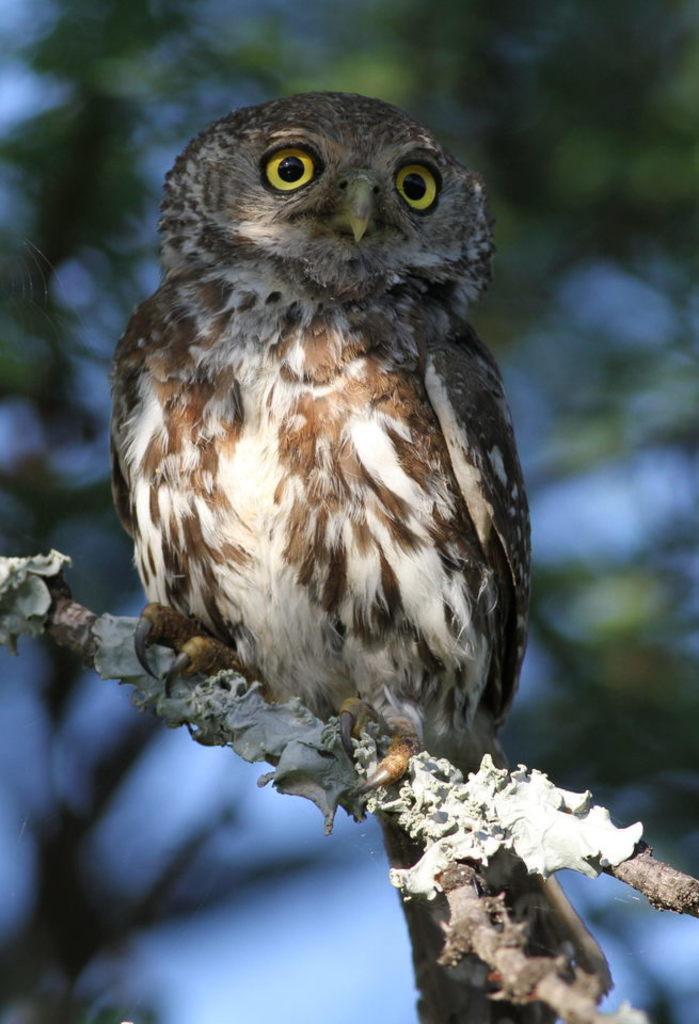In one or two sentences, can you explain what this image depicts? In this image we can see a bird sitting on a branch of the tree. We can see a tree in the image. There is a blur background in the image. 